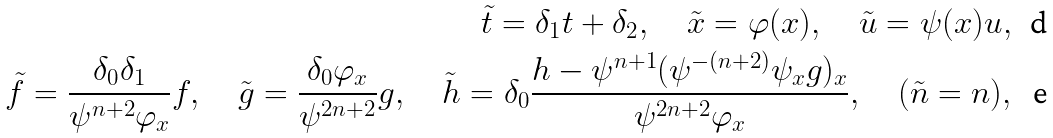Convert formula to latex. <formula><loc_0><loc_0><loc_500><loc_500>\tilde { t } = \delta _ { 1 } t + \delta _ { 2 } , \quad \tilde { x } = \varphi ( x ) , \quad \tilde { u } = \psi ( x ) u , \\ \tilde { f } = \frac { \delta _ { 0 } \delta _ { 1 } } { \psi ^ { n + 2 } \varphi _ { x } } f , \quad \tilde { g } = \frac { \delta _ { 0 } \varphi _ { x } } { \psi ^ { 2 n + 2 } } g , \quad \tilde { h } = \delta _ { 0 } \frac { h - \psi ^ { n + 1 } ( \psi ^ { - ( n + 2 ) } \psi _ { x } g ) _ { x } } { \psi ^ { 2 n + 2 } \varphi _ { x } } , \quad ( \tilde { n } = n ) ,</formula> 